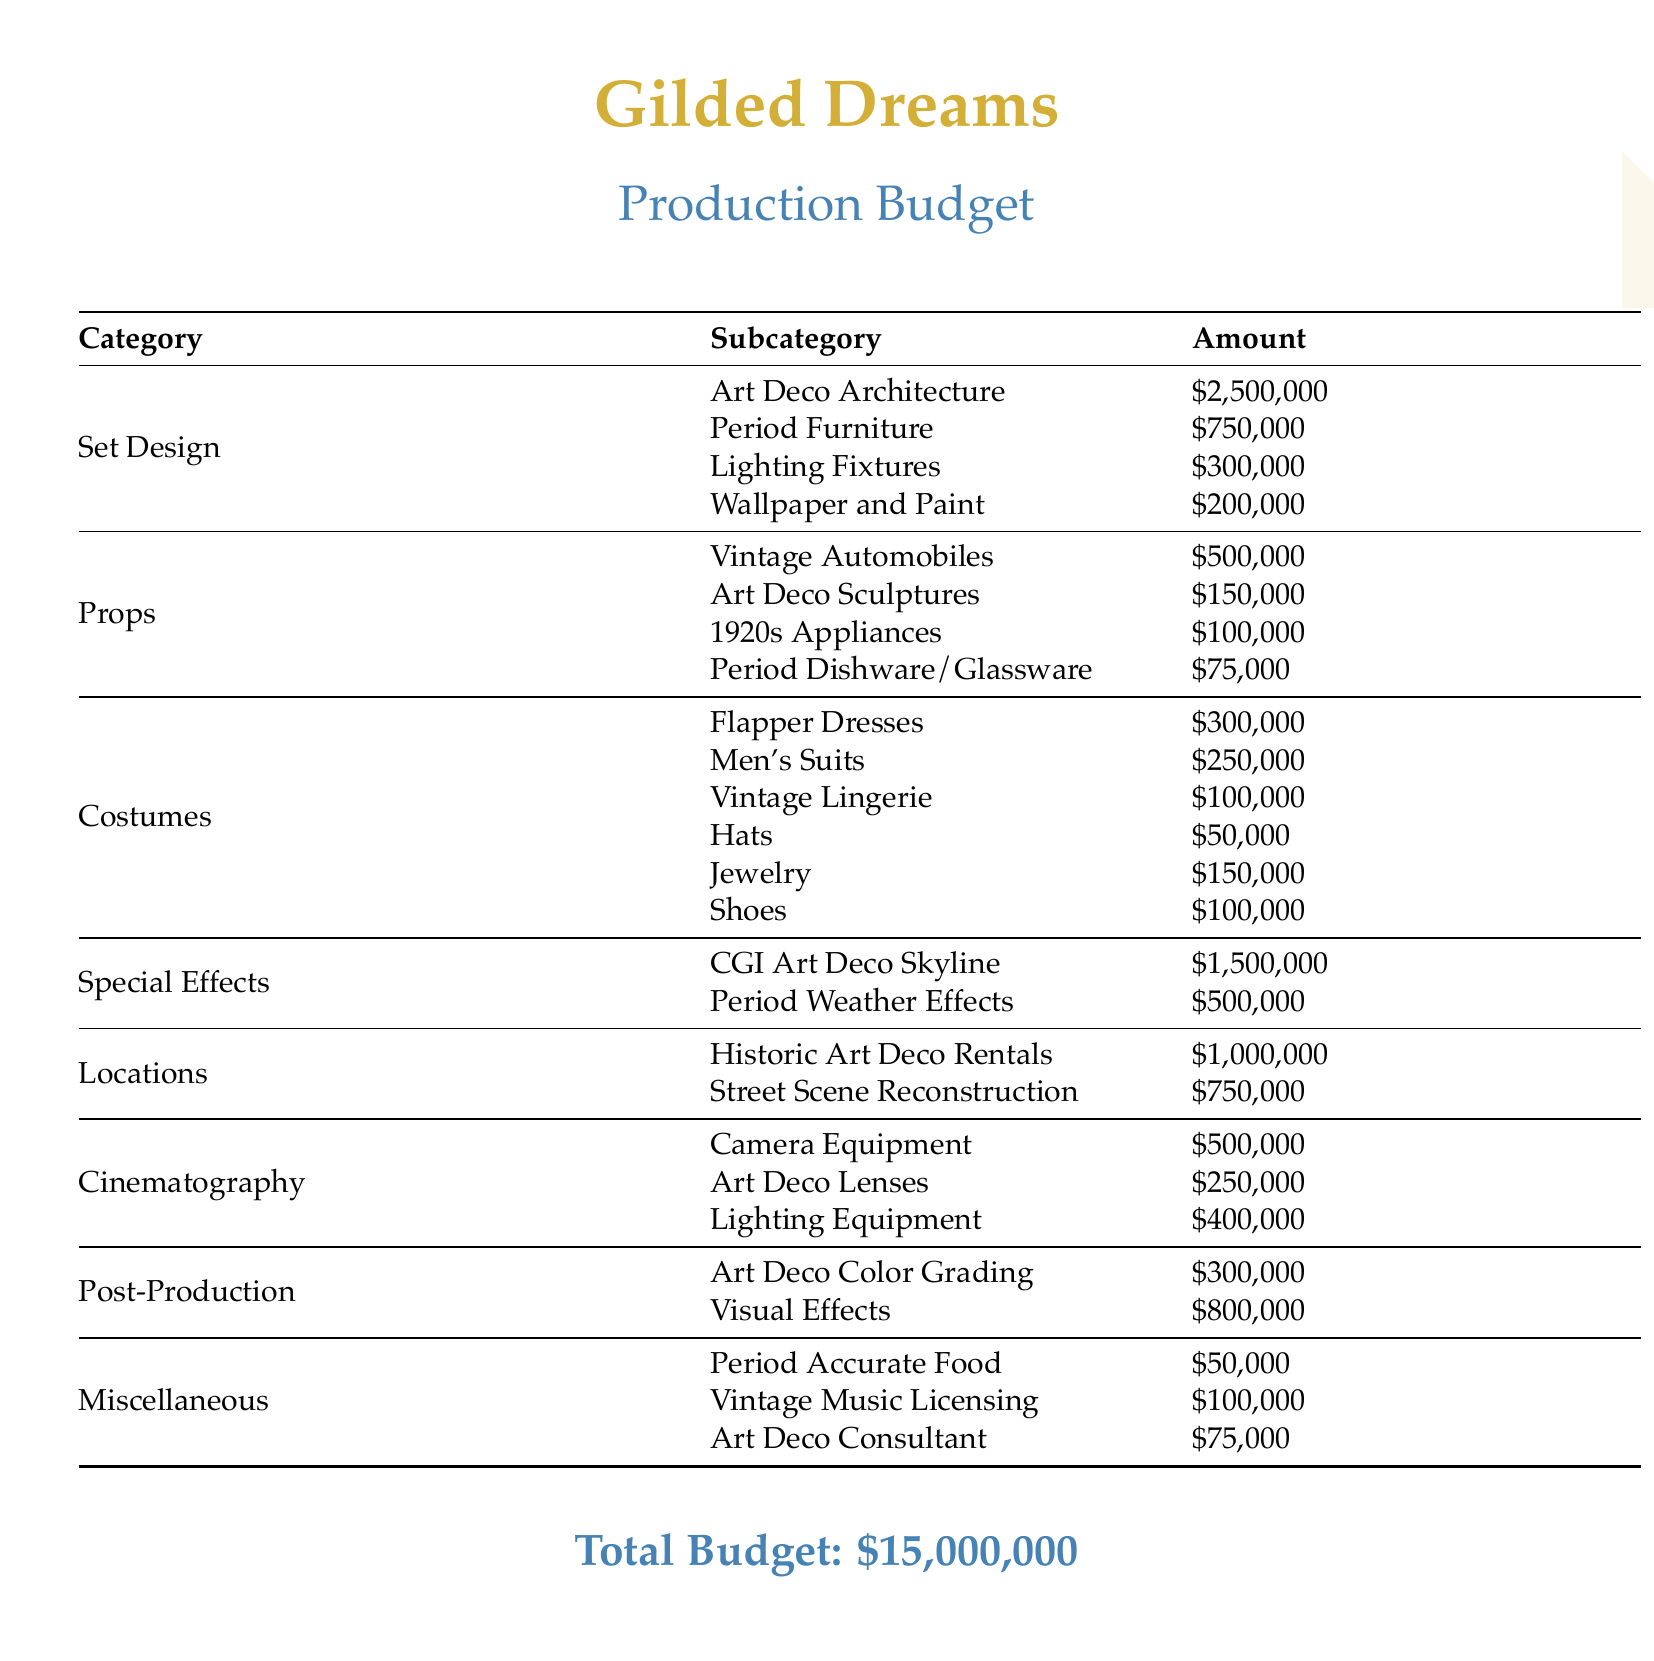What is the total budget? The total budget is found at the bottom of the document, summarizing the costs involved, which is $15,000,000.
Answer: $15,000,000 How much is allocated for Vintage Automobiles? The document specifies the amount allocated for Vintage Automobiles under the Props category as $500,000.
Answer: $500,000 What is the cost of Art Deco Architecture? The cost for Art Deco Architecture is listed under Set Design as $2,500,000.
Answer: $2,500,000 How much is spent on Flapper Dresses? The Flapper Dresses cost is detailed under Costumes and is stated as $300,000.
Answer: $300,000 What is the combined cost of CGI Art Deco Skyline and Period Weather Effects? To find the combined cost, one needs to add the amounts for CGI Art Deco Skyline, which is $1,500,000, and Period Weather Effects, which is $500,000.
Answer: $2,000,000 Which category has the highest expenditure? A review of all categories shows that Set Design has the highest expenditure among all categories, totaling $3,750,000.
Answer: Set Design What is the amount allocated for Art Deco Consultant? The amount allocated for Art Deco Consultant is listed under Miscellaneous as $75,000.
Answer: $75,000 How much is proposed for Art Deco Color Grading? The amount proposed for Art Deco Color Grading is noted under Post-Production as $300,000.
Answer: $300,000 What is the cost for Men’s Suits? The cost for Men's Suits is listed under Costumes as $250,000.
Answer: $250,000 